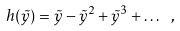<formula> <loc_0><loc_0><loc_500><loc_500>h ( \tilde { y } ) = \tilde { y } - \tilde { y } ^ { 2 } + \tilde { y } ^ { 3 } + \dots \ ,</formula> 